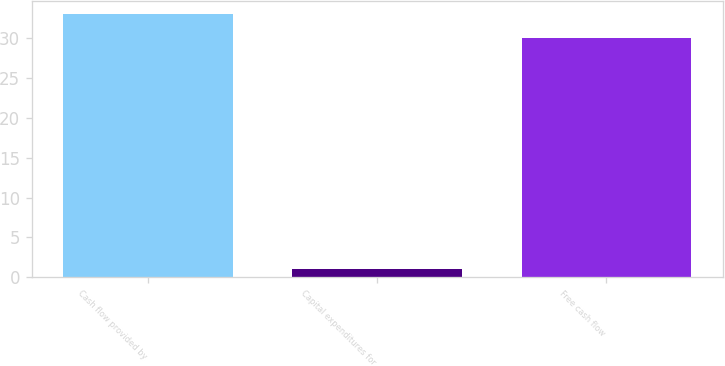Convert chart. <chart><loc_0><loc_0><loc_500><loc_500><bar_chart><fcel>Cash flow provided by<fcel>Capital expenditures for<fcel>Free cash flow<nl><fcel>33<fcel>1.1<fcel>30<nl></chart> 